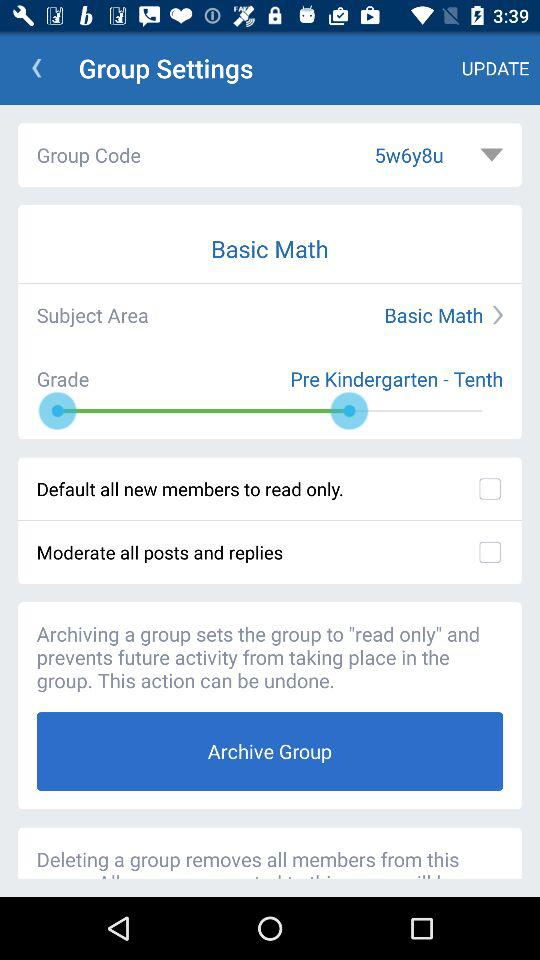How many check boxes are there on the screen?
Answer the question using a single word or phrase. 2 